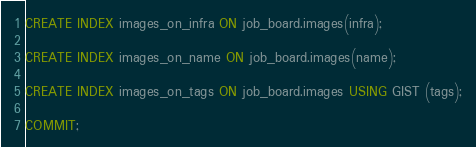Convert code to text. <code><loc_0><loc_0><loc_500><loc_500><_SQL_>CREATE INDEX images_on_infra ON job_board.images(infra);

CREATE INDEX images_on_name ON job_board.images(name);

CREATE INDEX images_on_tags ON job_board.images USING GIST (tags);

COMMIT;
</code> 